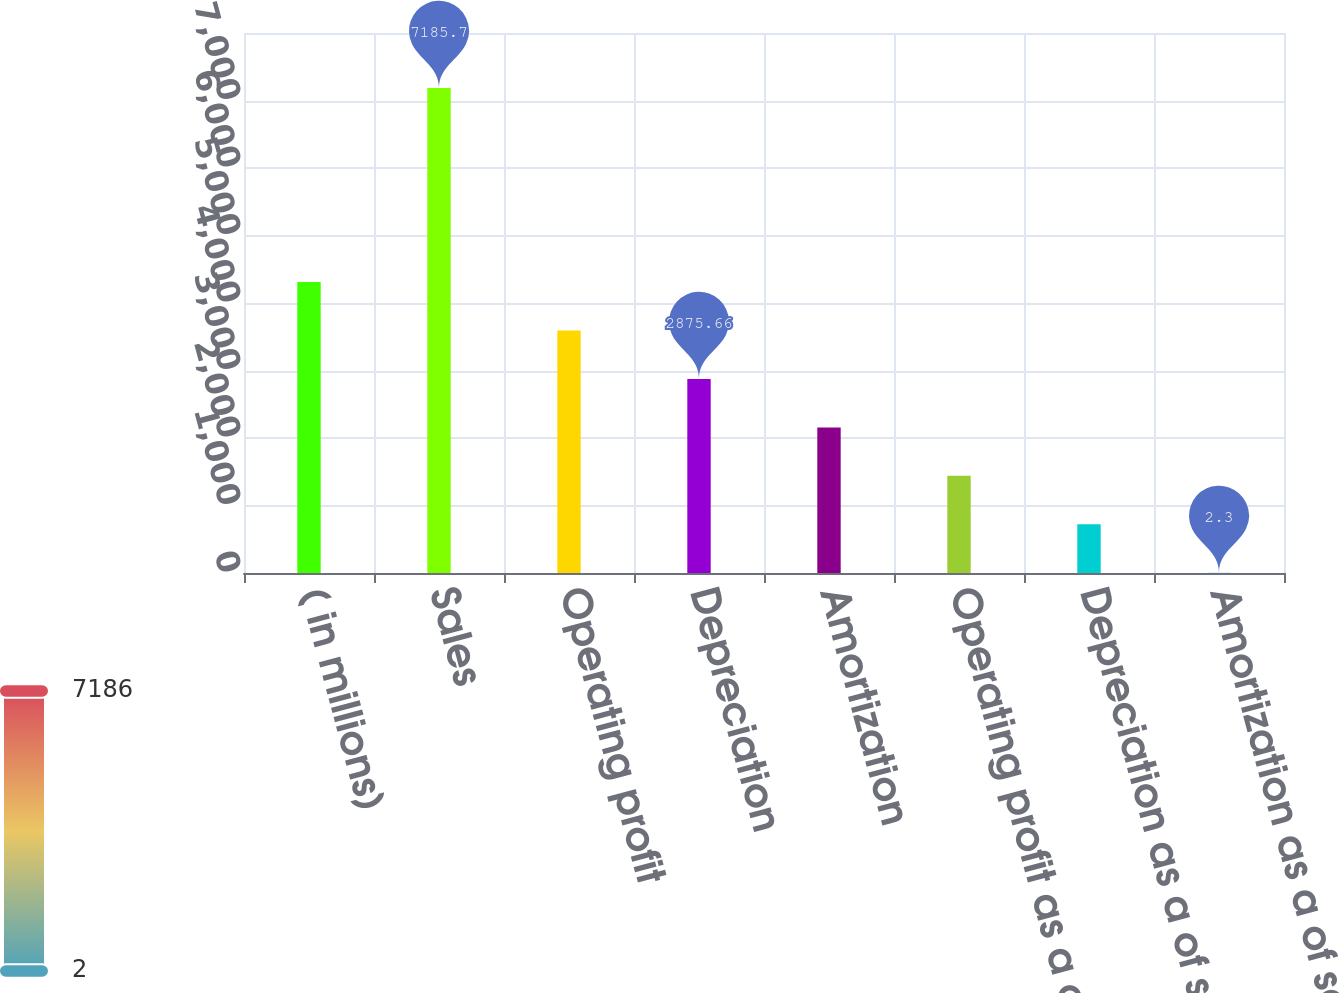<chart> <loc_0><loc_0><loc_500><loc_500><bar_chart><fcel>( in millions)<fcel>Sales<fcel>Operating profit<fcel>Depreciation<fcel>Amortization<fcel>Operating profit as a of sales<fcel>Depreciation as a of sales<fcel>Amortization as a of sales<nl><fcel>4312.34<fcel>7185.7<fcel>3594<fcel>2875.66<fcel>2157.32<fcel>1438.98<fcel>720.64<fcel>2.3<nl></chart> 